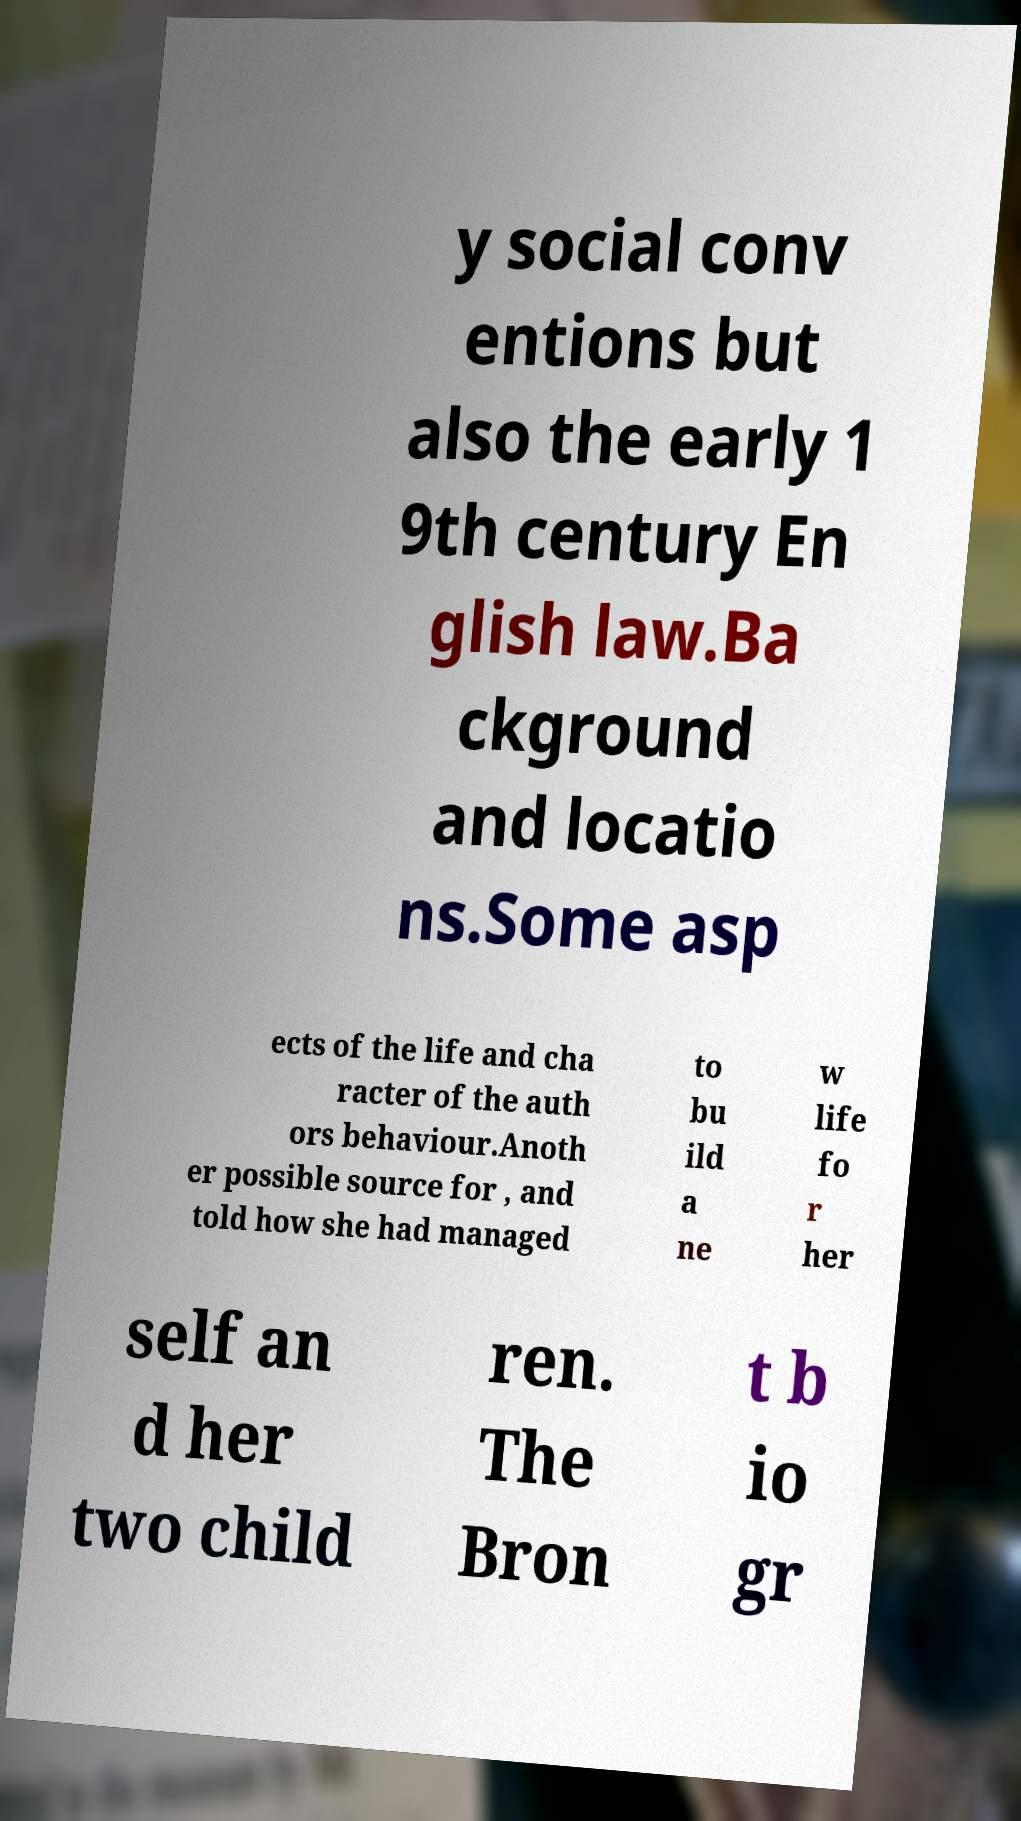Please read and relay the text visible in this image. What does it say? y social conv entions but also the early 1 9th century En glish law.Ba ckground and locatio ns.Some asp ects of the life and cha racter of the auth ors behaviour.Anoth er possible source for , and told how she had managed to bu ild a ne w life fo r her self an d her two child ren. The Bron t b io gr 